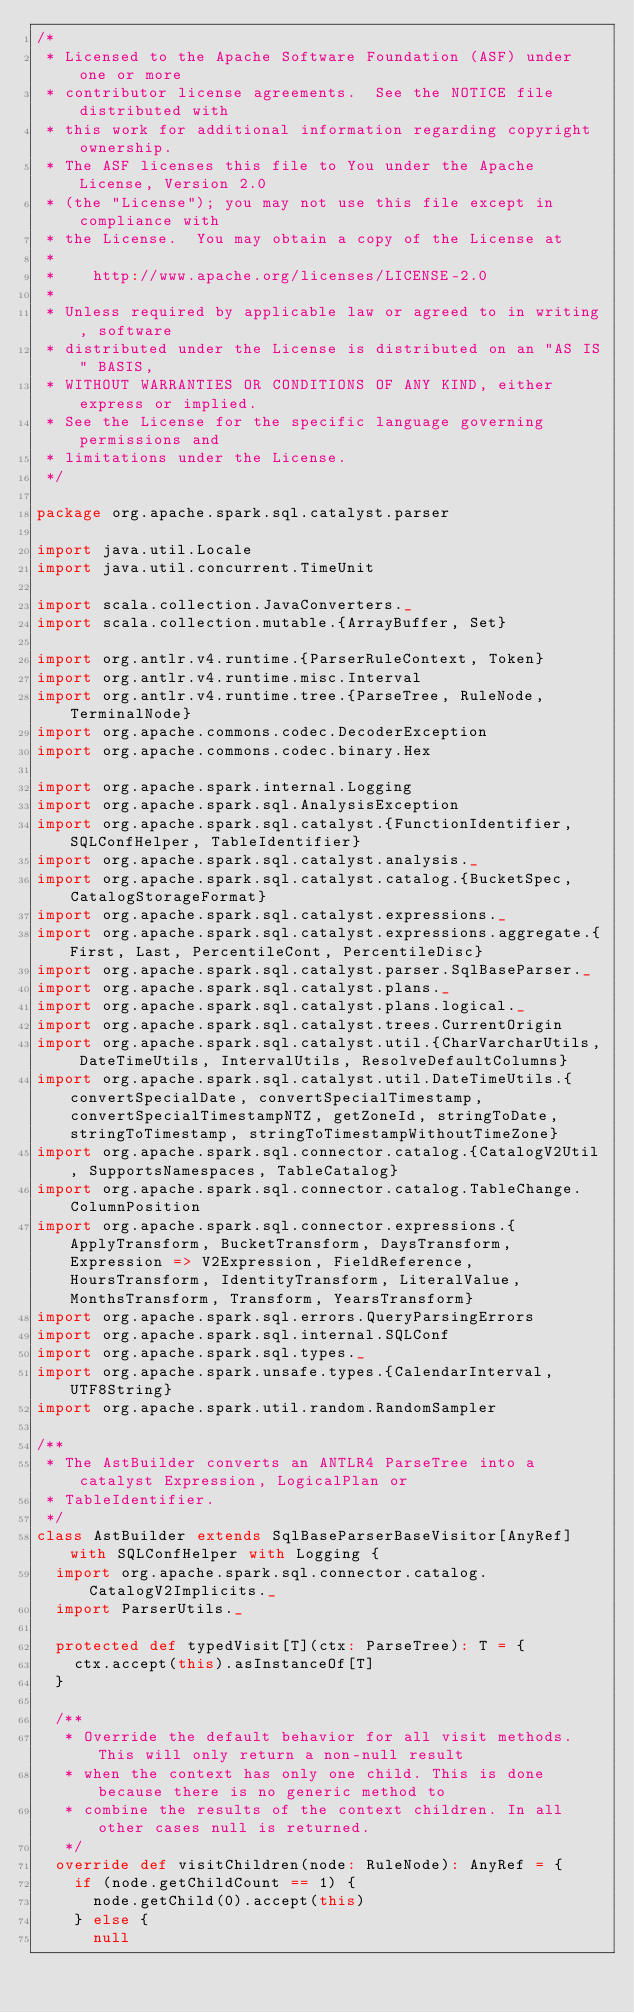<code> <loc_0><loc_0><loc_500><loc_500><_Scala_>/*
 * Licensed to the Apache Software Foundation (ASF) under one or more
 * contributor license agreements.  See the NOTICE file distributed with
 * this work for additional information regarding copyright ownership.
 * The ASF licenses this file to You under the Apache License, Version 2.0
 * (the "License"); you may not use this file except in compliance with
 * the License.  You may obtain a copy of the License at
 *
 *    http://www.apache.org/licenses/LICENSE-2.0
 *
 * Unless required by applicable law or agreed to in writing, software
 * distributed under the License is distributed on an "AS IS" BASIS,
 * WITHOUT WARRANTIES OR CONDITIONS OF ANY KIND, either express or implied.
 * See the License for the specific language governing permissions and
 * limitations under the License.
 */

package org.apache.spark.sql.catalyst.parser

import java.util.Locale
import java.util.concurrent.TimeUnit

import scala.collection.JavaConverters._
import scala.collection.mutable.{ArrayBuffer, Set}

import org.antlr.v4.runtime.{ParserRuleContext, Token}
import org.antlr.v4.runtime.misc.Interval
import org.antlr.v4.runtime.tree.{ParseTree, RuleNode, TerminalNode}
import org.apache.commons.codec.DecoderException
import org.apache.commons.codec.binary.Hex

import org.apache.spark.internal.Logging
import org.apache.spark.sql.AnalysisException
import org.apache.spark.sql.catalyst.{FunctionIdentifier, SQLConfHelper, TableIdentifier}
import org.apache.spark.sql.catalyst.analysis._
import org.apache.spark.sql.catalyst.catalog.{BucketSpec, CatalogStorageFormat}
import org.apache.spark.sql.catalyst.expressions._
import org.apache.spark.sql.catalyst.expressions.aggregate.{First, Last, PercentileCont, PercentileDisc}
import org.apache.spark.sql.catalyst.parser.SqlBaseParser._
import org.apache.spark.sql.catalyst.plans._
import org.apache.spark.sql.catalyst.plans.logical._
import org.apache.spark.sql.catalyst.trees.CurrentOrigin
import org.apache.spark.sql.catalyst.util.{CharVarcharUtils, DateTimeUtils, IntervalUtils, ResolveDefaultColumns}
import org.apache.spark.sql.catalyst.util.DateTimeUtils.{convertSpecialDate, convertSpecialTimestamp, convertSpecialTimestampNTZ, getZoneId, stringToDate, stringToTimestamp, stringToTimestampWithoutTimeZone}
import org.apache.spark.sql.connector.catalog.{CatalogV2Util, SupportsNamespaces, TableCatalog}
import org.apache.spark.sql.connector.catalog.TableChange.ColumnPosition
import org.apache.spark.sql.connector.expressions.{ApplyTransform, BucketTransform, DaysTransform, Expression => V2Expression, FieldReference, HoursTransform, IdentityTransform, LiteralValue, MonthsTransform, Transform, YearsTransform}
import org.apache.spark.sql.errors.QueryParsingErrors
import org.apache.spark.sql.internal.SQLConf
import org.apache.spark.sql.types._
import org.apache.spark.unsafe.types.{CalendarInterval, UTF8String}
import org.apache.spark.util.random.RandomSampler

/**
 * The AstBuilder converts an ANTLR4 ParseTree into a catalyst Expression, LogicalPlan or
 * TableIdentifier.
 */
class AstBuilder extends SqlBaseParserBaseVisitor[AnyRef] with SQLConfHelper with Logging {
  import org.apache.spark.sql.connector.catalog.CatalogV2Implicits._
  import ParserUtils._

  protected def typedVisit[T](ctx: ParseTree): T = {
    ctx.accept(this).asInstanceOf[T]
  }

  /**
   * Override the default behavior for all visit methods. This will only return a non-null result
   * when the context has only one child. This is done because there is no generic method to
   * combine the results of the context children. In all other cases null is returned.
   */
  override def visitChildren(node: RuleNode): AnyRef = {
    if (node.getChildCount == 1) {
      node.getChild(0).accept(this)
    } else {
      null</code> 